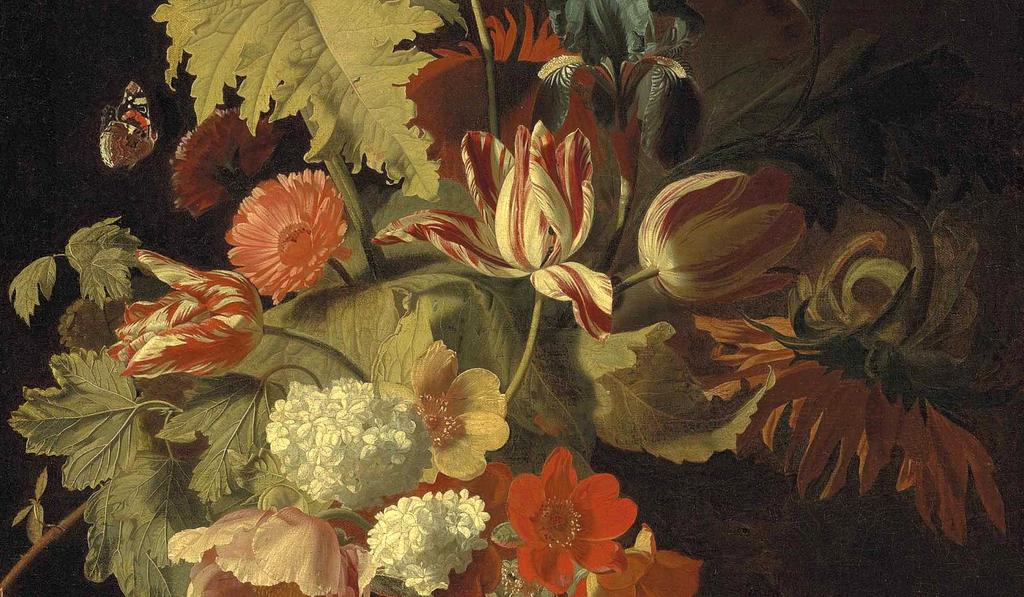What type of artwork is depicted in the image? The image is a painting. What natural elements can be seen in the painting? There are flowers, leaves, and a stem in the painting. Are there any other objects present in the painting besides the natural elements? Yes, there are other objects in the painting. What type of collar is featured on the dog in the painting? There is no dog or collar present in the painting; it features flowers, leaves, and other objects. Can you hear the bell ringing in the painting? There is no bell present in the painting; it is a still image and cannot produce sound. 